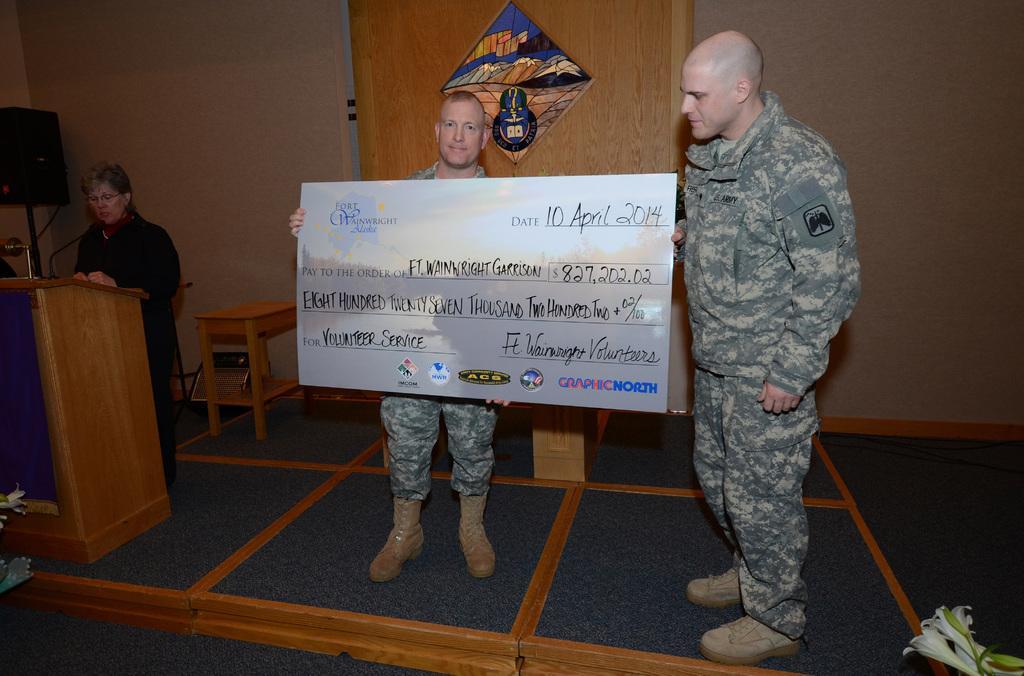Can you describe this image briefly? This picture describe about the two military men standing on the stage and receiving the cheque. Beside we can see women wearing black coat is giving a speech near the speech desk. Behind We can see black speaker and wooden panel in the center on which military symbol can be seen. 